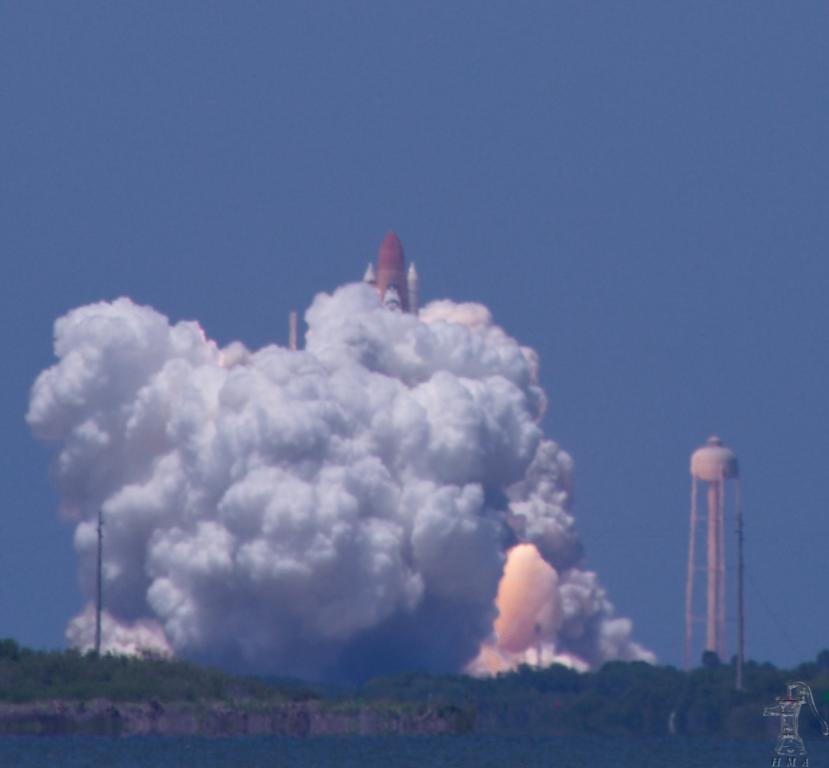How would you summarize this image in a sentence or two? In this image there are trees, a tank, rocket ,there is smoke, and in the background there is sky and a watermark on the image. 